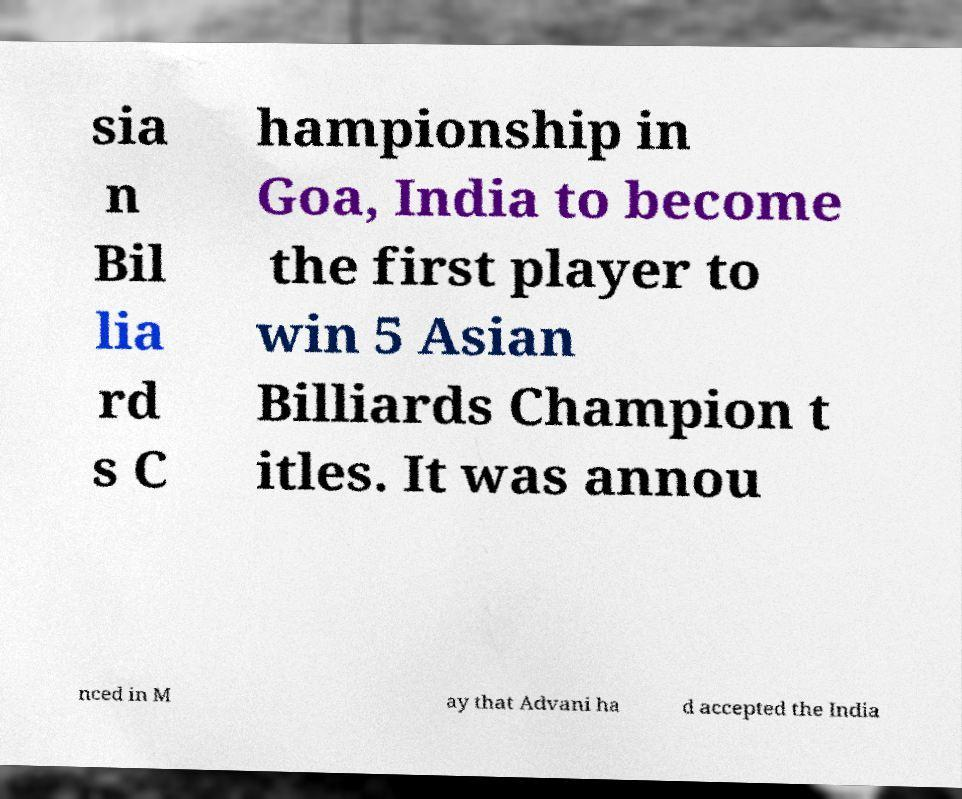Please identify and transcribe the text found in this image. sia n Bil lia rd s C hampionship in Goa, India to become the first player to win 5 Asian Billiards Champion t itles. It was annou nced in M ay that Advani ha d accepted the India 